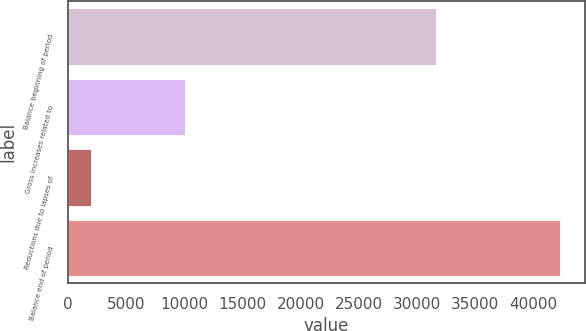<chart> <loc_0><loc_0><loc_500><loc_500><bar_chart><fcel>Balance beginning of period<fcel>Gross increases related to<fcel>Reductions due to lapses of<fcel>Balance end of period<nl><fcel>31672<fcel>10043.8<fcel>1983<fcel>42287<nl></chart> 